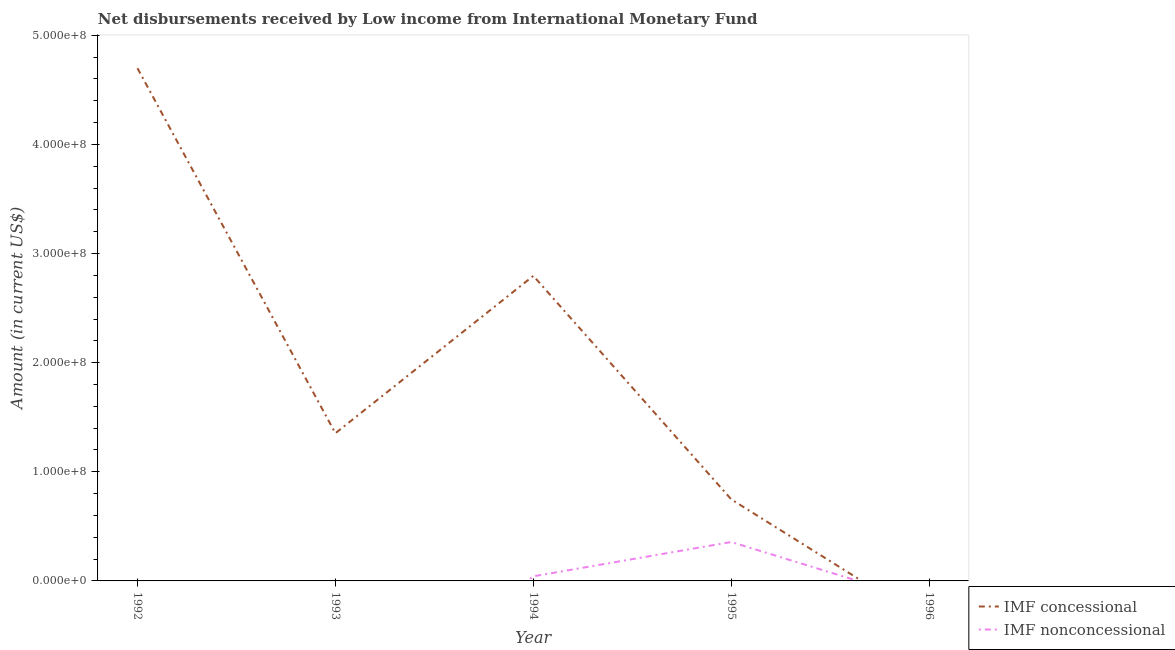Does the line corresponding to net non concessional disbursements from imf intersect with the line corresponding to net concessional disbursements from imf?
Keep it short and to the point. Yes. Is the number of lines equal to the number of legend labels?
Provide a short and direct response. No. What is the net concessional disbursements from imf in 1993?
Make the answer very short. 1.35e+08. Across all years, what is the maximum net non concessional disbursements from imf?
Give a very brief answer. 3.56e+07. Across all years, what is the minimum net concessional disbursements from imf?
Provide a succinct answer. 0. In which year was the net concessional disbursements from imf maximum?
Make the answer very short. 1992. What is the total net concessional disbursements from imf in the graph?
Offer a very short reply. 9.59e+08. What is the difference between the net concessional disbursements from imf in 1994 and that in 1995?
Give a very brief answer. 2.05e+08. What is the difference between the net concessional disbursements from imf in 1994 and the net non concessional disbursements from imf in 1993?
Provide a succinct answer. 2.80e+08. What is the average net non concessional disbursements from imf per year?
Provide a short and direct response. 7.98e+06. In the year 1994, what is the difference between the net non concessional disbursements from imf and net concessional disbursements from imf?
Ensure brevity in your answer.  -2.75e+08. What is the ratio of the net concessional disbursements from imf in 1993 to that in 1995?
Your answer should be very brief. 1.81. What is the difference between the highest and the second highest net concessional disbursements from imf?
Your answer should be compact. 1.90e+08. What is the difference between the highest and the lowest net concessional disbursements from imf?
Ensure brevity in your answer.  4.70e+08. Does the net concessional disbursements from imf monotonically increase over the years?
Provide a succinct answer. No. Is the net concessional disbursements from imf strictly greater than the net non concessional disbursements from imf over the years?
Give a very brief answer. No. Is the net non concessional disbursements from imf strictly less than the net concessional disbursements from imf over the years?
Keep it short and to the point. No. Does the graph contain grids?
Your answer should be very brief. No. Where does the legend appear in the graph?
Offer a very short reply. Bottom right. How are the legend labels stacked?
Give a very brief answer. Vertical. What is the title of the graph?
Keep it short and to the point. Net disbursements received by Low income from International Monetary Fund. Does "Short-term debt" appear as one of the legend labels in the graph?
Make the answer very short. No. What is the label or title of the X-axis?
Provide a short and direct response. Year. What is the label or title of the Y-axis?
Provide a succinct answer. Amount (in current US$). What is the Amount (in current US$) of IMF concessional in 1992?
Offer a very short reply. 4.70e+08. What is the Amount (in current US$) in IMF nonconcessional in 1992?
Keep it short and to the point. 0. What is the Amount (in current US$) of IMF concessional in 1993?
Ensure brevity in your answer.  1.35e+08. What is the Amount (in current US$) in IMF concessional in 1994?
Your answer should be very brief. 2.80e+08. What is the Amount (in current US$) of IMF nonconcessional in 1994?
Give a very brief answer. 4.24e+06. What is the Amount (in current US$) in IMF concessional in 1995?
Keep it short and to the point. 7.47e+07. What is the Amount (in current US$) of IMF nonconcessional in 1995?
Give a very brief answer. 3.56e+07. What is the Amount (in current US$) of IMF concessional in 1996?
Your answer should be very brief. 0. What is the Amount (in current US$) in IMF nonconcessional in 1996?
Offer a terse response. 0. Across all years, what is the maximum Amount (in current US$) in IMF concessional?
Your answer should be very brief. 4.70e+08. Across all years, what is the maximum Amount (in current US$) in IMF nonconcessional?
Make the answer very short. 3.56e+07. What is the total Amount (in current US$) in IMF concessional in the graph?
Provide a short and direct response. 9.59e+08. What is the total Amount (in current US$) of IMF nonconcessional in the graph?
Make the answer very short. 3.99e+07. What is the difference between the Amount (in current US$) of IMF concessional in 1992 and that in 1993?
Offer a very short reply. 3.34e+08. What is the difference between the Amount (in current US$) of IMF concessional in 1992 and that in 1994?
Keep it short and to the point. 1.90e+08. What is the difference between the Amount (in current US$) in IMF concessional in 1992 and that in 1995?
Provide a short and direct response. 3.95e+08. What is the difference between the Amount (in current US$) in IMF concessional in 1993 and that in 1994?
Offer a terse response. -1.44e+08. What is the difference between the Amount (in current US$) in IMF concessional in 1993 and that in 1995?
Give a very brief answer. 6.06e+07. What is the difference between the Amount (in current US$) of IMF concessional in 1994 and that in 1995?
Ensure brevity in your answer.  2.05e+08. What is the difference between the Amount (in current US$) in IMF nonconcessional in 1994 and that in 1995?
Your answer should be very brief. -3.14e+07. What is the difference between the Amount (in current US$) in IMF concessional in 1992 and the Amount (in current US$) in IMF nonconcessional in 1994?
Offer a very short reply. 4.66e+08. What is the difference between the Amount (in current US$) in IMF concessional in 1992 and the Amount (in current US$) in IMF nonconcessional in 1995?
Provide a short and direct response. 4.34e+08. What is the difference between the Amount (in current US$) of IMF concessional in 1993 and the Amount (in current US$) of IMF nonconcessional in 1994?
Ensure brevity in your answer.  1.31e+08. What is the difference between the Amount (in current US$) in IMF concessional in 1993 and the Amount (in current US$) in IMF nonconcessional in 1995?
Make the answer very short. 9.97e+07. What is the difference between the Amount (in current US$) in IMF concessional in 1994 and the Amount (in current US$) in IMF nonconcessional in 1995?
Make the answer very short. 2.44e+08. What is the average Amount (in current US$) in IMF concessional per year?
Your answer should be compact. 1.92e+08. What is the average Amount (in current US$) of IMF nonconcessional per year?
Provide a succinct answer. 7.98e+06. In the year 1994, what is the difference between the Amount (in current US$) in IMF concessional and Amount (in current US$) in IMF nonconcessional?
Ensure brevity in your answer.  2.75e+08. In the year 1995, what is the difference between the Amount (in current US$) in IMF concessional and Amount (in current US$) in IMF nonconcessional?
Offer a terse response. 3.91e+07. What is the ratio of the Amount (in current US$) in IMF concessional in 1992 to that in 1993?
Give a very brief answer. 3.47. What is the ratio of the Amount (in current US$) of IMF concessional in 1992 to that in 1994?
Provide a short and direct response. 1.68. What is the ratio of the Amount (in current US$) of IMF concessional in 1992 to that in 1995?
Keep it short and to the point. 6.29. What is the ratio of the Amount (in current US$) of IMF concessional in 1993 to that in 1994?
Offer a terse response. 0.48. What is the ratio of the Amount (in current US$) in IMF concessional in 1993 to that in 1995?
Your response must be concise. 1.81. What is the ratio of the Amount (in current US$) of IMF concessional in 1994 to that in 1995?
Keep it short and to the point. 3.74. What is the ratio of the Amount (in current US$) in IMF nonconcessional in 1994 to that in 1995?
Provide a short and direct response. 0.12. What is the difference between the highest and the second highest Amount (in current US$) of IMF concessional?
Keep it short and to the point. 1.90e+08. What is the difference between the highest and the lowest Amount (in current US$) in IMF concessional?
Your response must be concise. 4.70e+08. What is the difference between the highest and the lowest Amount (in current US$) in IMF nonconcessional?
Give a very brief answer. 3.56e+07. 